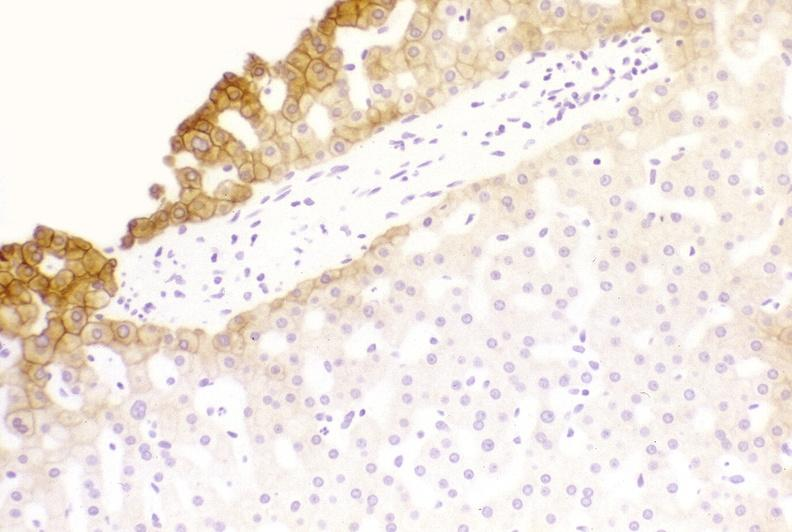what is present?
Answer the question using a single word or phrase. Hepatobiliary 